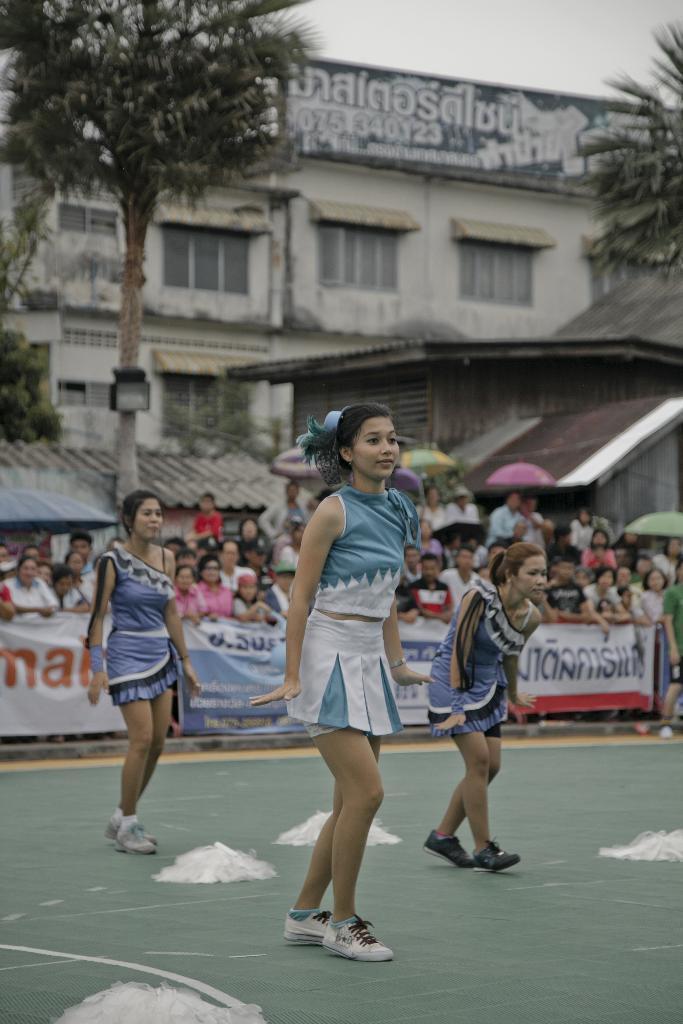Please provide a concise description of this image. In this image there are are three girls standing with a pose, behind them there are a few people standing, in front of them there is a banner, behind them there are trees, buildings and a lamp. 